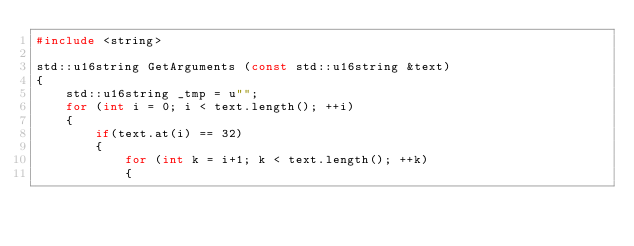<code> <loc_0><loc_0><loc_500><loc_500><_C++_>#include <string>

std::u16string GetArguments (const std::u16string &text)
{
	std::u16string _tmp = u"";
	for (int i = 0; i < text.length(); ++i)
	{
		if(text.at(i) == 32)
		{
			for (int k = i+1; k < text.length(); ++k)
			{</code> 